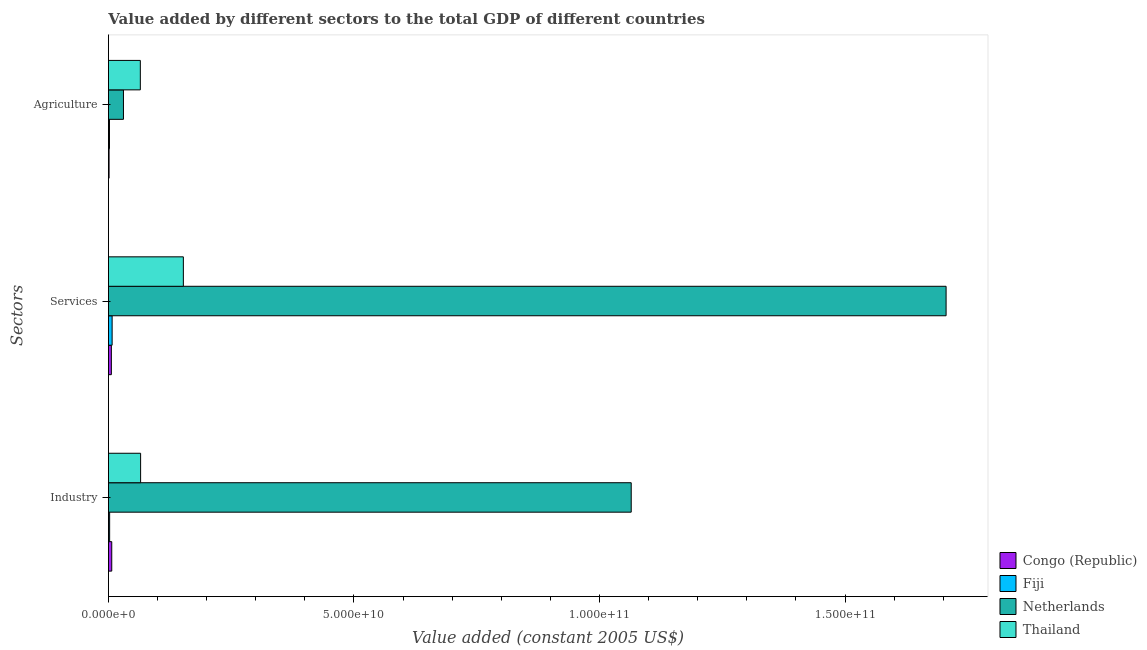How many groups of bars are there?
Make the answer very short. 3. Are the number of bars on each tick of the Y-axis equal?
Keep it short and to the point. Yes. How many bars are there on the 3rd tick from the bottom?
Your response must be concise. 4. What is the label of the 2nd group of bars from the top?
Ensure brevity in your answer.  Services. What is the value added by industrial sector in Congo (Republic)?
Offer a very short reply. 6.75e+08. Across all countries, what is the maximum value added by agricultural sector?
Provide a short and direct response. 6.50e+09. Across all countries, what is the minimum value added by industrial sector?
Ensure brevity in your answer.  2.45e+08. In which country was the value added by industrial sector maximum?
Provide a succinct answer. Netherlands. In which country was the value added by industrial sector minimum?
Provide a short and direct response. Fiji. What is the total value added by agricultural sector in the graph?
Give a very brief answer. 9.90e+09. What is the difference between the value added by industrial sector in Thailand and that in Netherlands?
Offer a terse response. -9.99e+1. What is the difference between the value added by agricultural sector in Congo (Republic) and the value added by services in Thailand?
Ensure brevity in your answer.  -1.51e+1. What is the average value added by services per country?
Keep it short and to the point. 4.68e+1. What is the difference between the value added by services and value added by industrial sector in Netherlands?
Your response must be concise. 6.41e+1. In how many countries, is the value added by services greater than 20000000000 US$?
Give a very brief answer. 1. What is the ratio of the value added by agricultural sector in Netherlands to that in Congo (Republic)?
Provide a succinct answer. 23.3. Is the value added by agricultural sector in Fiji less than that in Netherlands?
Keep it short and to the point. Yes. What is the difference between the highest and the second highest value added by industrial sector?
Offer a terse response. 9.99e+1. What is the difference between the highest and the lowest value added by services?
Provide a short and direct response. 1.70e+11. Is the sum of the value added by services in Netherlands and Fiji greater than the maximum value added by industrial sector across all countries?
Make the answer very short. Yes. What does the 4th bar from the bottom in Services represents?
Provide a short and direct response. Thailand. Is it the case that in every country, the sum of the value added by industrial sector and value added by services is greater than the value added by agricultural sector?
Offer a very short reply. Yes. How many bars are there?
Give a very brief answer. 12. Are all the bars in the graph horizontal?
Your answer should be very brief. Yes. How many countries are there in the graph?
Provide a short and direct response. 4. Are the values on the major ticks of X-axis written in scientific E-notation?
Give a very brief answer. Yes. Does the graph contain any zero values?
Give a very brief answer. No. Does the graph contain grids?
Keep it short and to the point. No. Where does the legend appear in the graph?
Provide a short and direct response. Bottom right. How many legend labels are there?
Make the answer very short. 4. What is the title of the graph?
Provide a succinct answer. Value added by different sectors to the total GDP of different countries. What is the label or title of the X-axis?
Make the answer very short. Value added (constant 2005 US$). What is the label or title of the Y-axis?
Provide a short and direct response. Sectors. What is the Value added (constant 2005 US$) in Congo (Republic) in Industry?
Provide a short and direct response. 6.75e+08. What is the Value added (constant 2005 US$) of Fiji in Industry?
Your answer should be very brief. 2.45e+08. What is the Value added (constant 2005 US$) of Netherlands in Industry?
Give a very brief answer. 1.06e+11. What is the Value added (constant 2005 US$) of Thailand in Industry?
Keep it short and to the point. 6.55e+09. What is the Value added (constant 2005 US$) of Congo (Republic) in Services?
Offer a terse response. 5.96e+08. What is the Value added (constant 2005 US$) of Fiji in Services?
Your answer should be compact. 7.51e+08. What is the Value added (constant 2005 US$) of Netherlands in Services?
Your response must be concise. 1.71e+11. What is the Value added (constant 2005 US$) of Thailand in Services?
Offer a very short reply. 1.53e+1. What is the Value added (constant 2005 US$) in Congo (Republic) in Agriculture?
Provide a short and direct response. 1.31e+08. What is the Value added (constant 2005 US$) in Fiji in Agriculture?
Ensure brevity in your answer.  2.12e+08. What is the Value added (constant 2005 US$) in Netherlands in Agriculture?
Your answer should be very brief. 3.06e+09. What is the Value added (constant 2005 US$) in Thailand in Agriculture?
Ensure brevity in your answer.  6.50e+09. Across all Sectors, what is the maximum Value added (constant 2005 US$) of Congo (Republic)?
Offer a very short reply. 6.75e+08. Across all Sectors, what is the maximum Value added (constant 2005 US$) of Fiji?
Your answer should be very brief. 7.51e+08. Across all Sectors, what is the maximum Value added (constant 2005 US$) in Netherlands?
Keep it short and to the point. 1.71e+11. Across all Sectors, what is the maximum Value added (constant 2005 US$) in Thailand?
Keep it short and to the point. 1.53e+1. Across all Sectors, what is the minimum Value added (constant 2005 US$) of Congo (Republic)?
Provide a succinct answer. 1.31e+08. Across all Sectors, what is the minimum Value added (constant 2005 US$) of Fiji?
Your answer should be very brief. 2.12e+08. Across all Sectors, what is the minimum Value added (constant 2005 US$) in Netherlands?
Provide a short and direct response. 3.06e+09. Across all Sectors, what is the minimum Value added (constant 2005 US$) of Thailand?
Ensure brevity in your answer.  6.50e+09. What is the total Value added (constant 2005 US$) of Congo (Republic) in the graph?
Provide a short and direct response. 1.40e+09. What is the total Value added (constant 2005 US$) in Fiji in the graph?
Offer a very short reply. 1.21e+09. What is the total Value added (constant 2005 US$) of Netherlands in the graph?
Offer a very short reply. 2.80e+11. What is the total Value added (constant 2005 US$) in Thailand in the graph?
Provide a short and direct response. 2.83e+1. What is the difference between the Value added (constant 2005 US$) of Congo (Republic) in Industry and that in Services?
Offer a very short reply. 7.90e+07. What is the difference between the Value added (constant 2005 US$) of Fiji in Industry and that in Services?
Ensure brevity in your answer.  -5.06e+08. What is the difference between the Value added (constant 2005 US$) of Netherlands in Industry and that in Services?
Give a very brief answer. -6.41e+1. What is the difference between the Value added (constant 2005 US$) of Thailand in Industry and that in Services?
Provide a short and direct response. -8.70e+09. What is the difference between the Value added (constant 2005 US$) in Congo (Republic) in Industry and that in Agriculture?
Your answer should be compact. 5.44e+08. What is the difference between the Value added (constant 2005 US$) of Fiji in Industry and that in Agriculture?
Make the answer very short. 3.27e+07. What is the difference between the Value added (constant 2005 US$) of Netherlands in Industry and that in Agriculture?
Ensure brevity in your answer.  1.03e+11. What is the difference between the Value added (constant 2005 US$) of Thailand in Industry and that in Agriculture?
Provide a short and direct response. 5.74e+07. What is the difference between the Value added (constant 2005 US$) in Congo (Republic) in Services and that in Agriculture?
Offer a terse response. 4.65e+08. What is the difference between the Value added (constant 2005 US$) in Fiji in Services and that in Agriculture?
Your answer should be compact. 5.39e+08. What is the difference between the Value added (constant 2005 US$) of Netherlands in Services and that in Agriculture?
Ensure brevity in your answer.  1.68e+11. What is the difference between the Value added (constant 2005 US$) in Thailand in Services and that in Agriculture?
Offer a very short reply. 8.76e+09. What is the difference between the Value added (constant 2005 US$) in Congo (Republic) in Industry and the Value added (constant 2005 US$) in Fiji in Services?
Provide a succinct answer. -7.64e+07. What is the difference between the Value added (constant 2005 US$) of Congo (Republic) in Industry and the Value added (constant 2005 US$) of Netherlands in Services?
Offer a terse response. -1.70e+11. What is the difference between the Value added (constant 2005 US$) of Congo (Republic) in Industry and the Value added (constant 2005 US$) of Thailand in Services?
Make the answer very short. -1.46e+1. What is the difference between the Value added (constant 2005 US$) in Fiji in Industry and the Value added (constant 2005 US$) in Netherlands in Services?
Keep it short and to the point. -1.70e+11. What is the difference between the Value added (constant 2005 US$) in Fiji in Industry and the Value added (constant 2005 US$) in Thailand in Services?
Give a very brief answer. -1.50e+1. What is the difference between the Value added (constant 2005 US$) in Netherlands in Industry and the Value added (constant 2005 US$) in Thailand in Services?
Provide a succinct answer. 9.12e+1. What is the difference between the Value added (constant 2005 US$) of Congo (Republic) in Industry and the Value added (constant 2005 US$) of Fiji in Agriculture?
Your answer should be very brief. 4.63e+08. What is the difference between the Value added (constant 2005 US$) in Congo (Republic) in Industry and the Value added (constant 2005 US$) in Netherlands in Agriculture?
Your answer should be very brief. -2.38e+09. What is the difference between the Value added (constant 2005 US$) in Congo (Republic) in Industry and the Value added (constant 2005 US$) in Thailand in Agriculture?
Provide a short and direct response. -5.82e+09. What is the difference between the Value added (constant 2005 US$) in Fiji in Industry and the Value added (constant 2005 US$) in Netherlands in Agriculture?
Offer a very short reply. -2.81e+09. What is the difference between the Value added (constant 2005 US$) of Fiji in Industry and the Value added (constant 2005 US$) of Thailand in Agriculture?
Your answer should be compact. -6.25e+09. What is the difference between the Value added (constant 2005 US$) of Netherlands in Industry and the Value added (constant 2005 US$) of Thailand in Agriculture?
Make the answer very short. 1.00e+11. What is the difference between the Value added (constant 2005 US$) of Congo (Republic) in Services and the Value added (constant 2005 US$) of Fiji in Agriculture?
Your answer should be compact. 3.84e+08. What is the difference between the Value added (constant 2005 US$) in Congo (Republic) in Services and the Value added (constant 2005 US$) in Netherlands in Agriculture?
Offer a terse response. -2.46e+09. What is the difference between the Value added (constant 2005 US$) in Congo (Republic) in Services and the Value added (constant 2005 US$) in Thailand in Agriculture?
Your answer should be compact. -5.90e+09. What is the difference between the Value added (constant 2005 US$) of Fiji in Services and the Value added (constant 2005 US$) of Netherlands in Agriculture?
Offer a terse response. -2.31e+09. What is the difference between the Value added (constant 2005 US$) in Fiji in Services and the Value added (constant 2005 US$) in Thailand in Agriculture?
Your answer should be very brief. -5.74e+09. What is the difference between the Value added (constant 2005 US$) in Netherlands in Services and the Value added (constant 2005 US$) in Thailand in Agriculture?
Your answer should be compact. 1.64e+11. What is the average Value added (constant 2005 US$) of Congo (Republic) per Sectors?
Offer a very short reply. 4.67e+08. What is the average Value added (constant 2005 US$) of Fiji per Sectors?
Your answer should be very brief. 4.03e+08. What is the average Value added (constant 2005 US$) of Netherlands per Sectors?
Your answer should be compact. 9.34e+1. What is the average Value added (constant 2005 US$) of Thailand per Sectors?
Your answer should be compact. 9.44e+09. What is the difference between the Value added (constant 2005 US$) of Congo (Republic) and Value added (constant 2005 US$) of Fiji in Industry?
Ensure brevity in your answer.  4.30e+08. What is the difference between the Value added (constant 2005 US$) of Congo (Republic) and Value added (constant 2005 US$) of Netherlands in Industry?
Provide a succinct answer. -1.06e+11. What is the difference between the Value added (constant 2005 US$) in Congo (Republic) and Value added (constant 2005 US$) in Thailand in Industry?
Provide a succinct answer. -5.88e+09. What is the difference between the Value added (constant 2005 US$) of Fiji and Value added (constant 2005 US$) of Netherlands in Industry?
Provide a succinct answer. -1.06e+11. What is the difference between the Value added (constant 2005 US$) in Fiji and Value added (constant 2005 US$) in Thailand in Industry?
Make the answer very short. -6.31e+09. What is the difference between the Value added (constant 2005 US$) in Netherlands and Value added (constant 2005 US$) in Thailand in Industry?
Provide a short and direct response. 9.99e+1. What is the difference between the Value added (constant 2005 US$) in Congo (Republic) and Value added (constant 2005 US$) in Fiji in Services?
Make the answer very short. -1.55e+08. What is the difference between the Value added (constant 2005 US$) in Congo (Republic) and Value added (constant 2005 US$) in Netherlands in Services?
Keep it short and to the point. -1.70e+11. What is the difference between the Value added (constant 2005 US$) of Congo (Republic) and Value added (constant 2005 US$) of Thailand in Services?
Keep it short and to the point. -1.47e+1. What is the difference between the Value added (constant 2005 US$) of Fiji and Value added (constant 2005 US$) of Netherlands in Services?
Your response must be concise. -1.70e+11. What is the difference between the Value added (constant 2005 US$) in Fiji and Value added (constant 2005 US$) in Thailand in Services?
Your answer should be very brief. -1.45e+1. What is the difference between the Value added (constant 2005 US$) in Netherlands and Value added (constant 2005 US$) in Thailand in Services?
Provide a short and direct response. 1.55e+11. What is the difference between the Value added (constant 2005 US$) in Congo (Republic) and Value added (constant 2005 US$) in Fiji in Agriculture?
Your answer should be compact. -8.11e+07. What is the difference between the Value added (constant 2005 US$) in Congo (Republic) and Value added (constant 2005 US$) in Netherlands in Agriculture?
Offer a terse response. -2.93e+09. What is the difference between the Value added (constant 2005 US$) of Congo (Republic) and Value added (constant 2005 US$) of Thailand in Agriculture?
Offer a terse response. -6.36e+09. What is the difference between the Value added (constant 2005 US$) of Fiji and Value added (constant 2005 US$) of Netherlands in Agriculture?
Offer a very short reply. -2.85e+09. What is the difference between the Value added (constant 2005 US$) of Fiji and Value added (constant 2005 US$) of Thailand in Agriculture?
Your answer should be very brief. -6.28e+09. What is the difference between the Value added (constant 2005 US$) of Netherlands and Value added (constant 2005 US$) of Thailand in Agriculture?
Make the answer very short. -3.44e+09. What is the ratio of the Value added (constant 2005 US$) in Congo (Republic) in Industry to that in Services?
Your response must be concise. 1.13. What is the ratio of the Value added (constant 2005 US$) of Fiji in Industry to that in Services?
Your response must be concise. 0.33. What is the ratio of the Value added (constant 2005 US$) in Netherlands in Industry to that in Services?
Keep it short and to the point. 0.62. What is the ratio of the Value added (constant 2005 US$) of Thailand in Industry to that in Services?
Your answer should be very brief. 0.43. What is the ratio of the Value added (constant 2005 US$) of Congo (Republic) in Industry to that in Agriculture?
Give a very brief answer. 5.14. What is the ratio of the Value added (constant 2005 US$) of Fiji in Industry to that in Agriculture?
Give a very brief answer. 1.15. What is the ratio of the Value added (constant 2005 US$) of Netherlands in Industry to that in Agriculture?
Provide a short and direct response. 34.8. What is the ratio of the Value added (constant 2005 US$) of Thailand in Industry to that in Agriculture?
Give a very brief answer. 1.01. What is the ratio of the Value added (constant 2005 US$) of Congo (Republic) in Services to that in Agriculture?
Give a very brief answer. 4.54. What is the ratio of the Value added (constant 2005 US$) of Fiji in Services to that in Agriculture?
Give a very brief answer. 3.54. What is the ratio of the Value added (constant 2005 US$) in Netherlands in Services to that in Agriculture?
Offer a terse response. 55.77. What is the ratio of the Value added (constant 2005 US$) in Thailand in Services to that in Agriculture?
Offer a very short reply. 2.35. What is the difference between the highest and the second highest Value added (constant 2005 US$) in Congo (Republic)?
Offer a terse response. 7.90e+07. What is the difference between the highest and the second highest Value added (constant 2005 US$) of Fiji?
Your answer should be compact. 5.06e+08. What is the difference between the highest and the second highest Value added (constant 2005 US$) in Netherlands?
Your answer should be very brief. 6.41e+1. What is the difference between the highest and the second highest Value added (constant 2005 US$) of Thailand?
Give a very brief answer. 8.70e+09. What is the difference between the highest and the lowest Value added (constant 2005 US$) of Congo (Republic)?
Your answer should be very brief. 5.44e+08. What is the difference between the highest and the lowest Value added (constant 2005 US$) in Fiji?
Give a very brief answer. 5.39e+08. What is the difference between the highest and the lowest Value added (constant 2005 US$) in Netherlands?
Offer a very short reply. 1.68e+11. What is the difference between the highest and the lowest Value added (constant 2005 US$) of Thailand?
Keep it short and to the point. 8.76e+09. 